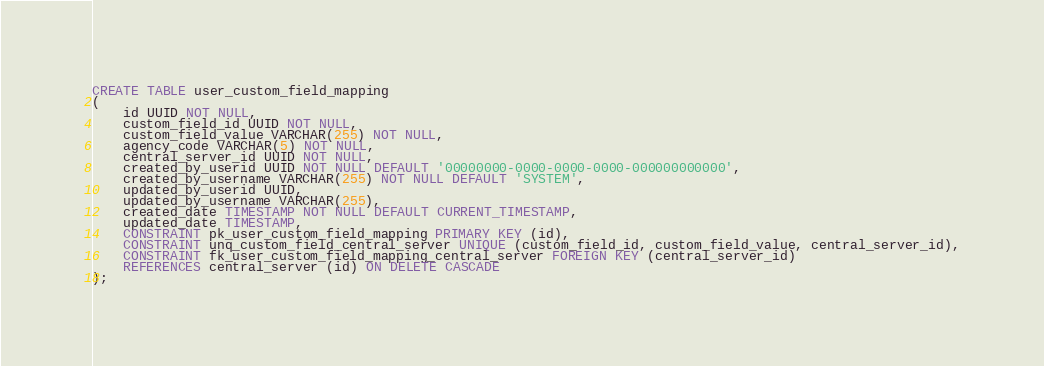Convert code to text. <code><loc_0><loc_0><loc_500><loc_500><_SQL_>CREATE TABLE user_custom_field_mapping
(
    id UUID NOT NULL,
    custom_field_id UUID NOT NULL,
    custom_field_value VARCHAR(255) NOT NULL,
    agency_code VARCHAR(5) NOT NULL,
    central_server_id UUID NOT NULL,
    created_by_userid UUID NOT NULL DEFAULT '00000000-0000-0000-0000-000000000000',
    created_by_username VARCHAR(255) NOT NULL DEFAULT 'SYSTEM',
    updated_by_userid UUID,
    updated_by_username VARCHAR(255),
    created_date TIMESTAMP NOT NULL DEFAULT CURRENT_TIMESTAMP,
    updated_date TIMESTAMP,
    CONSTRAINT pk_user_custom_field_mapping PRIMARY KEY (id),
    CONSTRAINT unq_custom_field_central_server UNIQUE (custom_field_id, custom_field_value, central_server_id),
    CONSTRAINT fk_user_custom_field_mapping_central_server FOREIGN KEY (central_server_id)
    REFERENCES central_server (id) ON DELETE CASCADE
);
</code> 